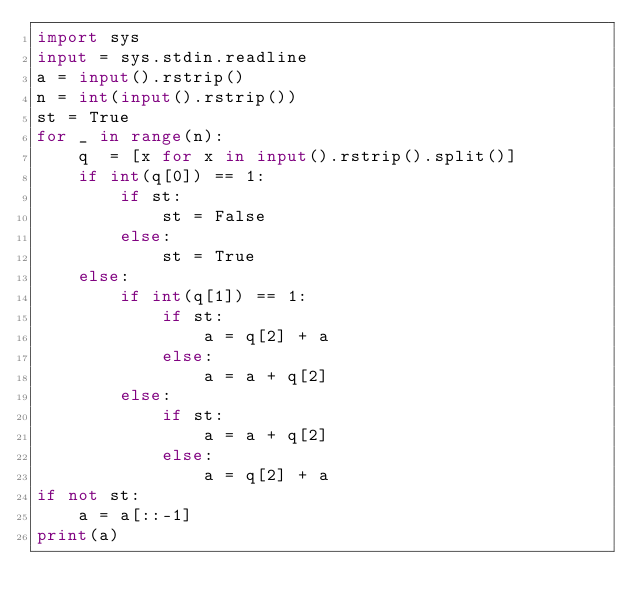<code> <loc_0><loc_0><loc_500><loc_500><_Python_>import sys
input = sys.stdin.readline
a = input().rstrip()
n = int(input().rstrip())
st = True
for _ in range(n):
    q  = [x for x in input().rstrip().split()]
    if int(q[0]) == 1:
        if st:
            st = False
        else:
            st = True
    else:
        if int(q[1]) == 1:
            if st:
                a = q[2] + a
            else:
                a = a + q[2]
        else:
            if st:
                a = a + q[2]
            else:
                a = q[2] + a
if not st:
    a = a[::-1]
print(a)</code> 